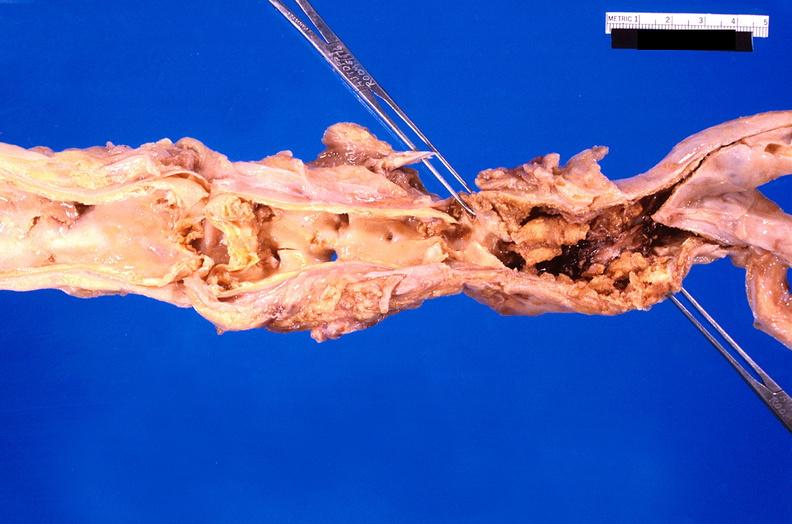does lesion show abdominal aorta saccular aneurysm, atherosclerosis?
Answer the question using a single word or phrase. No 